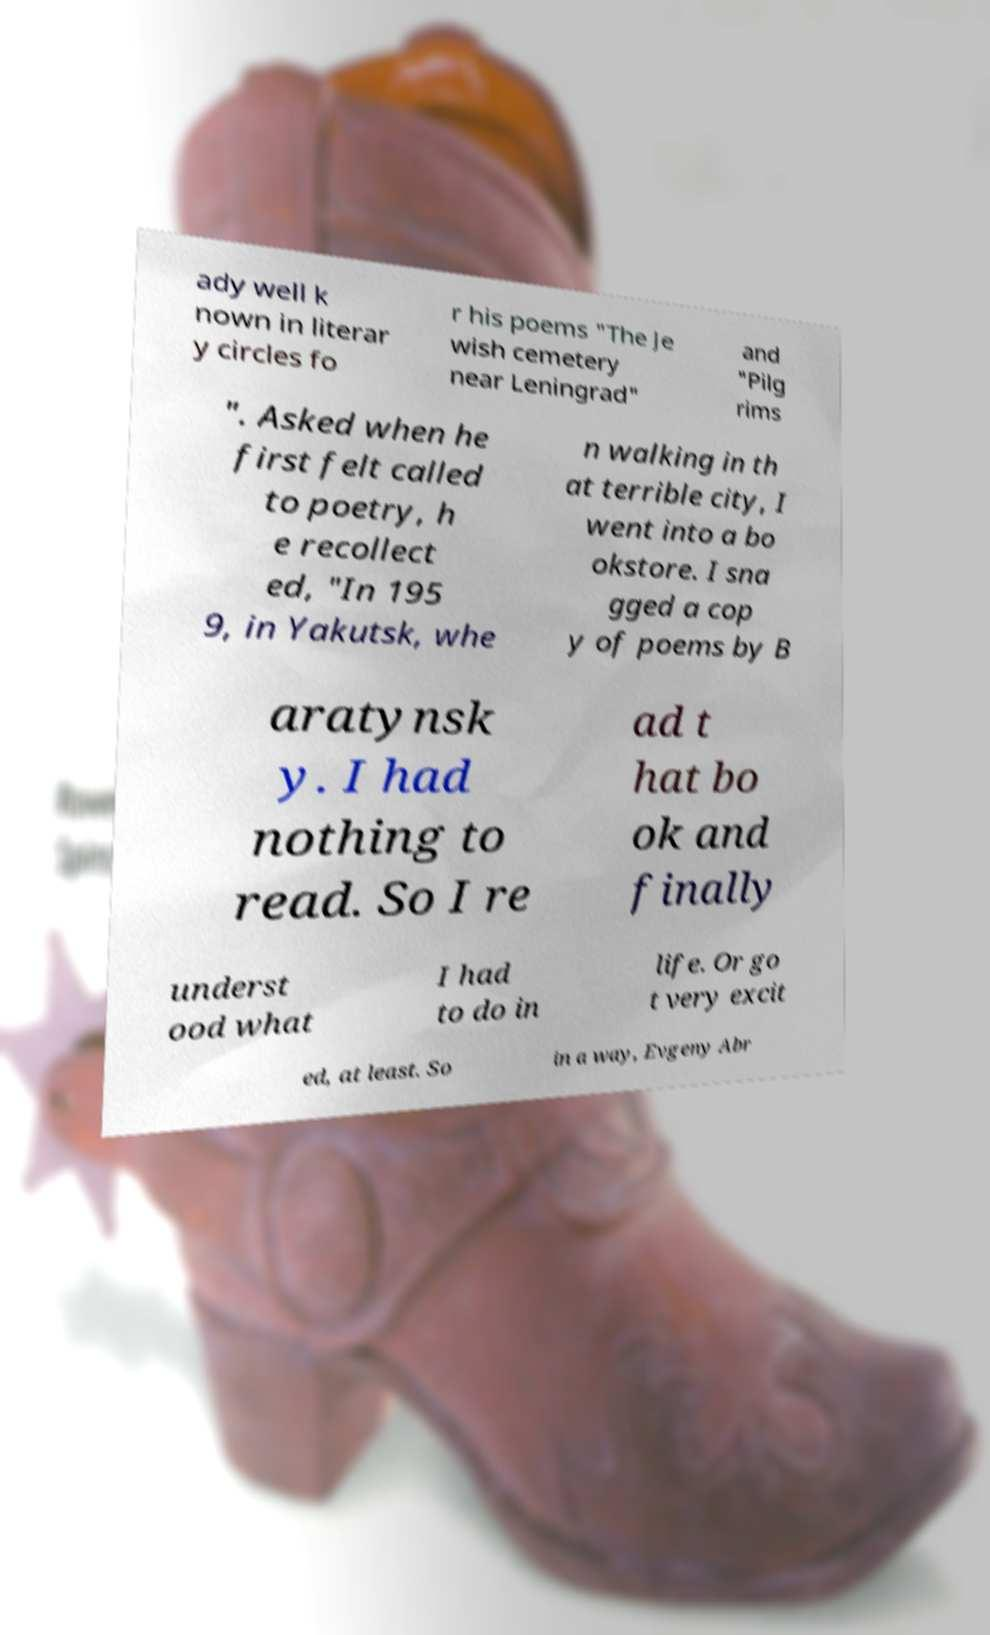I need the written content from this picture converted into text. Can you do that? ady well k nown in literar y circles fo r his poems "The Je wish cemetery near Leningrad" and "Pilg rims ". Asked when he first felt called to poetry, h e recollect ed, "In 195 9, in Yakutsk, whe n walking in th at terrible city, I went into a bo okstore. I sna gged a cop y of poems by B aratynsk y. I had nothing to read. So I re ad t hat bo ok and finally underst ood what I had to do in life. Or go t very excit ed, at least. So in a way, Evgeny Abr 